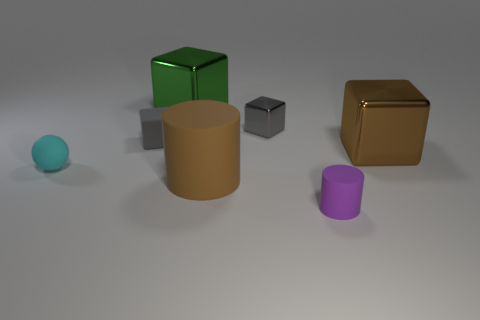Subtract all red cubes. Subtract all green balls. How many cubes are left? 4 Add 3 red cubes. How many objects exist? 10 Subtract all balls. How many objects are left? 6 Add 6 rubber cubes. How many rubber cubes are left? 7 Add 1 cyan balls. How many cyan balls exist? 2 Subtract 1 purple cylinders. How many objects are left? 6 Subtract all tiny yellow shiny cylinders. Subtract all tiny gray matte blocks. How many objects are left? 6 